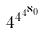Convert formula to latex. <formula><loc_0><loc_0><loc_500><loc_500>4 ^ { 4 ^ { 4 ^ { \aleph _ { 0 } } } }</formula> 